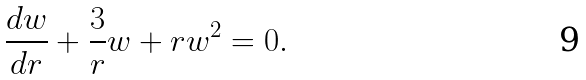Convert formula to latex. <formula><loc_0><loc_0><loc_500><loc_500>\frac { d w } { d r } + \frac { 3 } { r } w + r w ^ { 2 } = 0 .</formula> 